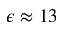<formula> <loc_0><loc_0><loc_500><loc_500>\epsilon \approx 1 3</formula> 